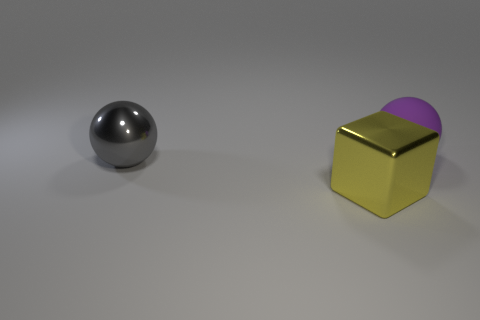There is another object that is the same shape as the big purple matte object; what is its material?
Your answer should be very brief. Metal. Is there any other thing that is the same size as the yellow cube?
Offer a terse response. Yes. There is a object right of the large yellow thing; is it the same color as the metal thing that is behind the big yellow shiny thing?
Your answer should be compact. No. The large yellow thing is what shape?
Give a very brief answer. Cube. Is the number of big purple balls that are left of the large yellow object greater than the number of big gray metallic balls?
Make the answer very short. No. What is the shape of the big metal object that is on the left side of the large yellow object?
Make the answer very short. Sphere. How many other things are the same shape as the big yellow metal object?
Provide a short and direct response. 0. Do the big sphere on the right side of the big yellow thing and the yellow cube have the same material?
Give a very brief answer. No. Are there the same number of large purple balls behind the gray shiny object and big rubber balls on the left side of the purple matte object?
Your answer should be very brief. No. There is a object to the right of the shiny cube; what size is it?
Ensure brevity in your answer.  Large. 